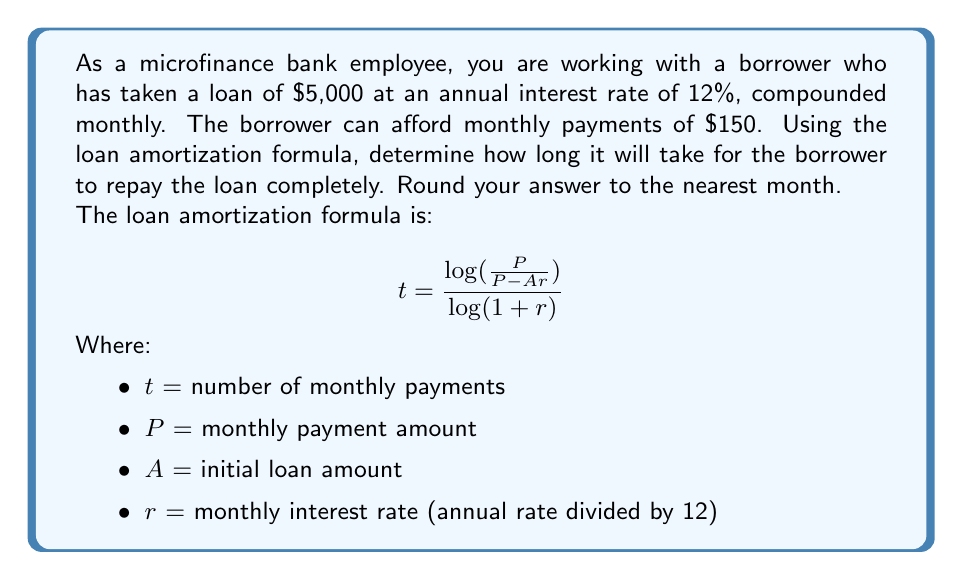What is the answer to this math problem? To solve this problem, we'll use the given loan amortization formula and follow these steps:

1. Identify the known values:
   $P = 150$ (monthly payment)
   $A = 5000$ (initial loan amount)
   Annual interest rate = 12%

2. Calculate the monthly interest rate:
   $r = \frac{12\%}{12} = 0.01$ or 1% per month

3. Substitute these values into the formula:

   $$t = \frac{\log(\frac{150}{150 - 5000 \cdot 0.01})}{\log(1 + 0.01)}$$

4. Simplify the numerator:
   $\frac{150}{150 - 5000 \cdot 0.01} = \frac{150}{150 - 50} = \frac{150}{100} = 1.5$

   $$t = \frac{\log(1.5)}{\log(1.01)}$$

5. Calculate using a scientific calculator or logarithm tables:
   $\log(1.5) \approx 0.17609125905568124$
   $\log(1.01) \approx 0.004364805402450088$

   $$t = \frac{0.17609125905568124}{0.004364805402450088} \approx 40.34$$

6. Round to the nearest month:
   $t \approx 40$ months

Therefore, it will take approximately 40 months for the borrower to repay the loan completely.
Answer: 40 months 